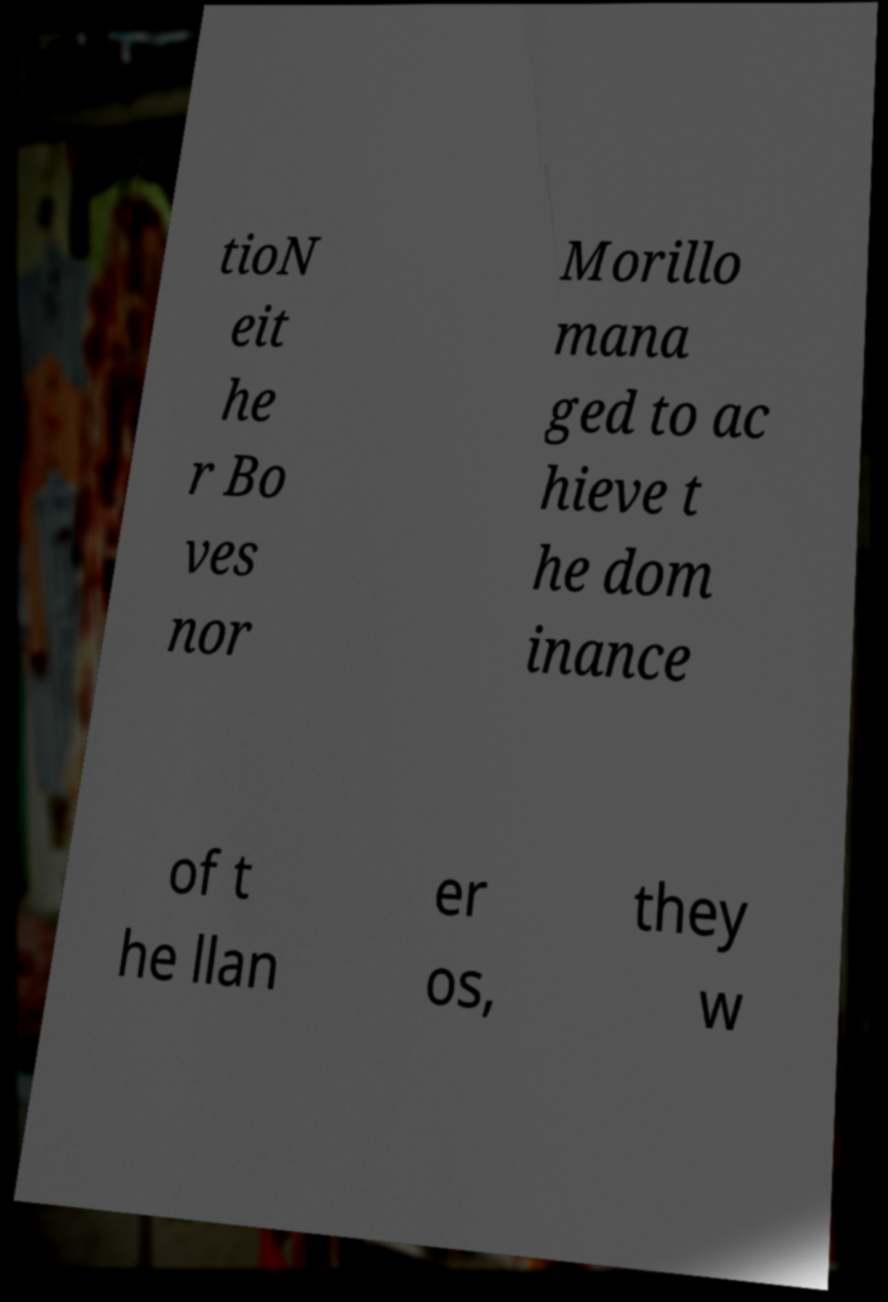Can you read and provide the text displayed in the image?This photo seems to have some interesting text. Can you extract and type it out for me? tioN eit he r Bo ves nor Morillo mana ged to ac hieve t he dom inance of t he llan er os, they w 